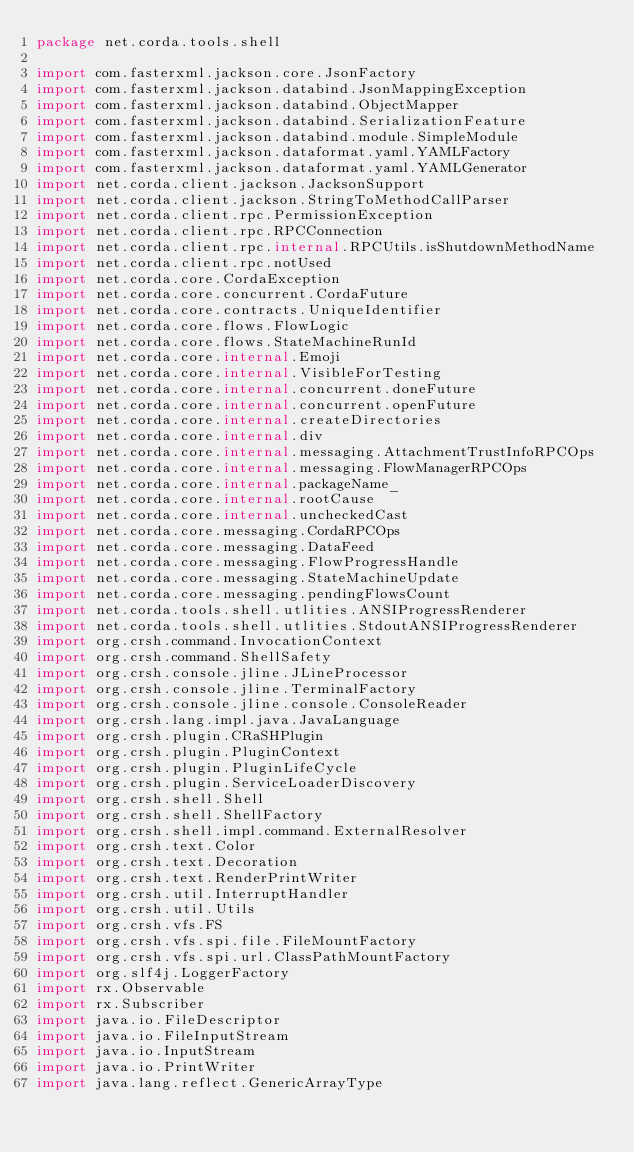<code> <loc_0><loc_0><loc_500><loc_500><_Kotlin_>package net.corda.tools.shell

import com.fasterxml.jackson.core.JsonFactory
import com.fasterxml.jackson.databind.JsonMappingException
import com.fasterxml.jackson.databind.ObjectMapper
import com.fasterxml.jackson.databind.SerializationFeature
import com.fasterxml.jackson.databind.module.SimpleModule
import com.fasterxml.jackson.dataformat.yaml.YAMLFactory
import com.fasterxml.jackson.dataformat.yaml.YAMLGenerator
import net.corda.client.jackson.JacksonSupport
import net.corda.client.jackson.StringToMethodCallParser
import net.corda.client.rpc.PermissionException
import net.corda.client.rpc.RPCConnection
import net.corda.client.rpc.internal.RPCUtils.isShutdownMethodName
import net.corda.client.rpc.notUsed
import net.corda.core.CordaException
import net.corda.core.concurrent.CordaFuture
import net.corda.core.contracts.UniqueIdentifier
import net.corda.core.flows.FlowLogic
import net.corda.core.flows.StateMachineRunId
import net.corda.core.internal.Emoji
import net.corda.core.internal.VisibleForTesting
import net.corda.core.internal.concurrent.doneFuture
import net.corda.core.internal.concurrent.openFuture
import net.corda.core.internal.createDirectories
import net.corda.core.internal.div
import net.corda.core.internal.messaging.AttachmentTrustInfoRPCOps
import net.corda.core.internal.messaging.FlowManagerRPCOps
import net.corda.core.internal.packageName_
import net.corda.core.internal.rootCause
import net.corda.core.internal.uncheckedCast
import net.corda.core.messaging.CordaRPCOps
import net.corda.core.messaging.DataFeed
import net.corda.core.messaging.FlowProgressHandle
import net.corda.core.messaging.StateMachineUpdate
import net.corda.core.messaging.pendingFlowsCount
import net.corda.tools.shell.utlities.ANSIProgressRenderer
import net.corda.tools.shell.utlities.StdoutANSIProgressRenderer
import org.crsh.command.InvocationContext
import org.crsh.command.ShellSafety
import org.crsh.console.jline.JLineProcessor
import org.crsh.console.jline.TerminalFactory
import org.crsh.console.jline.console.ConsoleReader
import org.crsh.lang.impl.java.JavaLanguage
import org.crsh.plugin.CRaSHPlugin
import org.crsh.plugin.PluginContext
import org.crsh.plugin.PluginLifeCycle
import org.crsh.plugin.ServiceLoaderDiscovery
import org.crsh.shell.Shell
import org.crsh.shell.ShellFactory
import org.crsh.shell.impl.command.ExternalResolver
import org.crsh.text.Color
import org.crsh.text.Decoration
import org.crsh.text.RenderPrintWriter
import org.crsh.util.InterruptHandler
import org.crsh.util.Utils
import org.crsh.vfs.FS
import org.crsh.vfs.spi.file.FileMountFactory
import org.crsh.vfs.spi.url.ClassPathMountFactory
import org.slf4j.LoggerFactory
import rx.Observable
import rx.Subscriber
import java.io.FileDescriptor
import java.io.FileInputStream
import java.io.InputStream
import java.io.PrintWriter
import java.lang.reflect.GenericArrayType</code> 